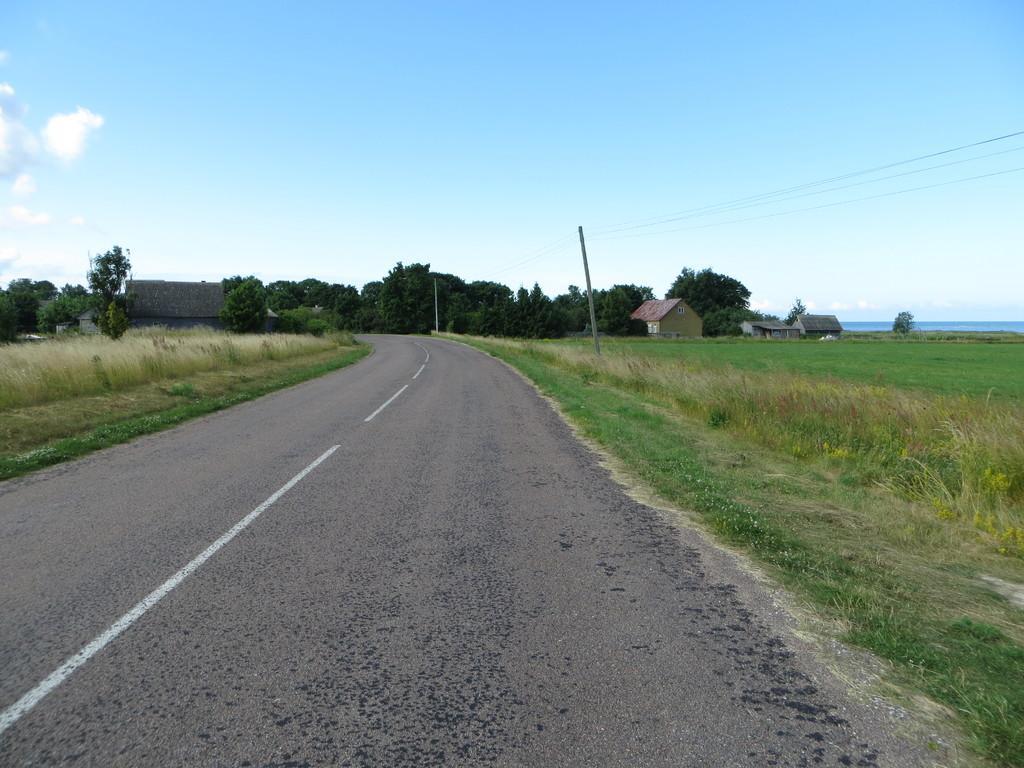Can you describe this image briefly? In this image I can see the road in the center towards the bottom of the image. I can see grass, trees and crops on both sides of the road. I can see some houses and trees in the center of the image. At the top of the image I can see the sky. 